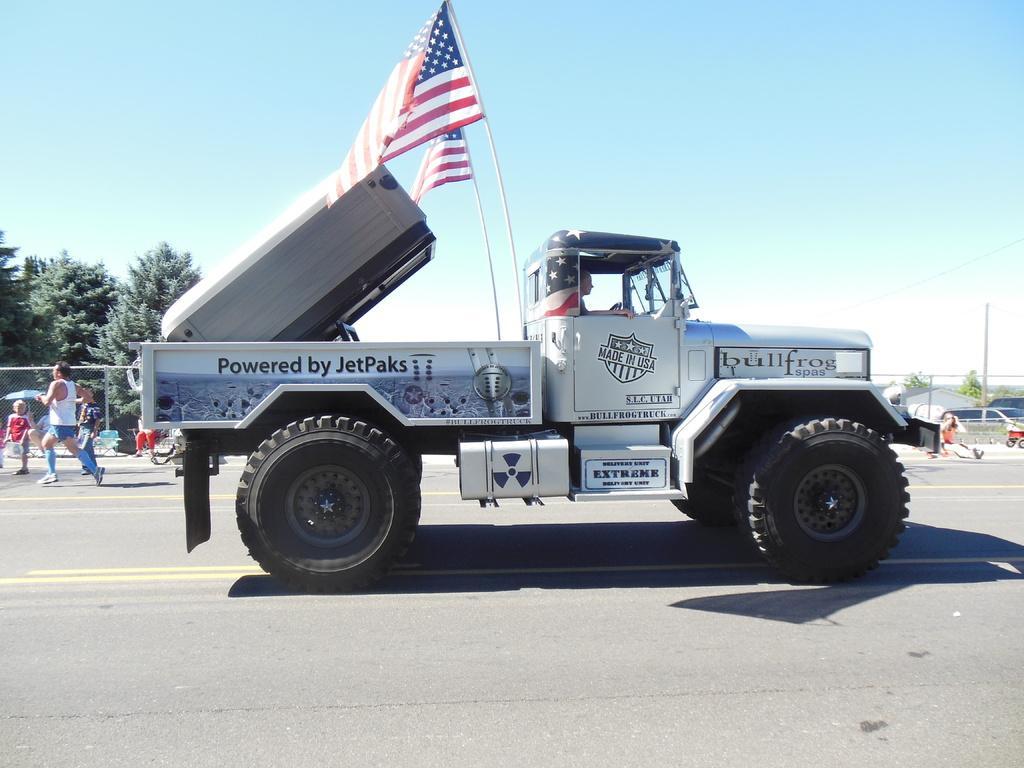Please provide a concise description of this image. In this image I can see the road, a vehicle which is white and black in color on the road. I can see a person sitting in the vehicle and two flags attached to the vehicle. In the background I can see few persons are standing on the road, few trees, few buildings and the sky. 